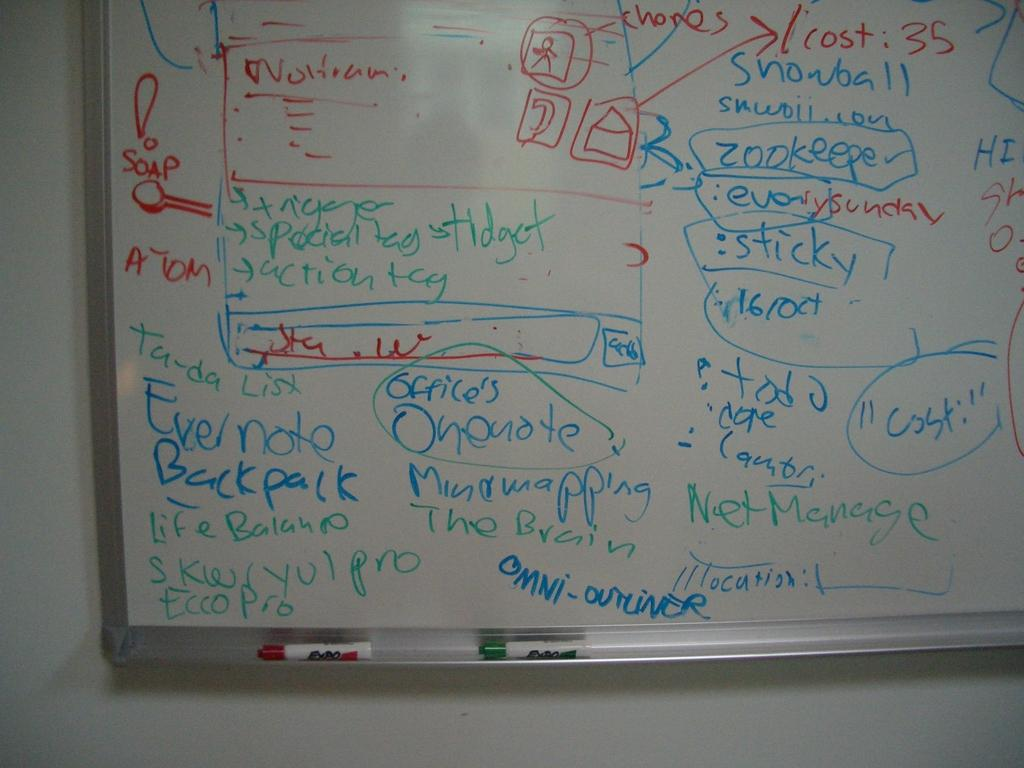<image>
Relay a brief, clear account of the picture shown. White board includes names and diagrams with expo markers 